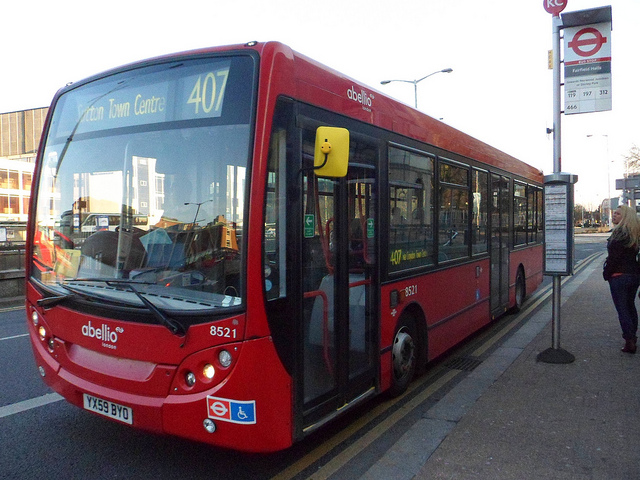Identify the text contained in this image. 407 Centre Town abellio 8521 BYD KC YX59 